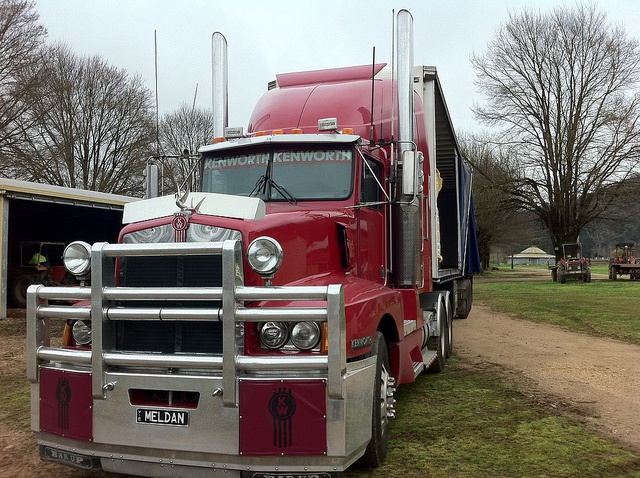Describe the objects in this image and their specific colors. I can see a truck in lightgray, gray, black, and maroon tones in this image. 